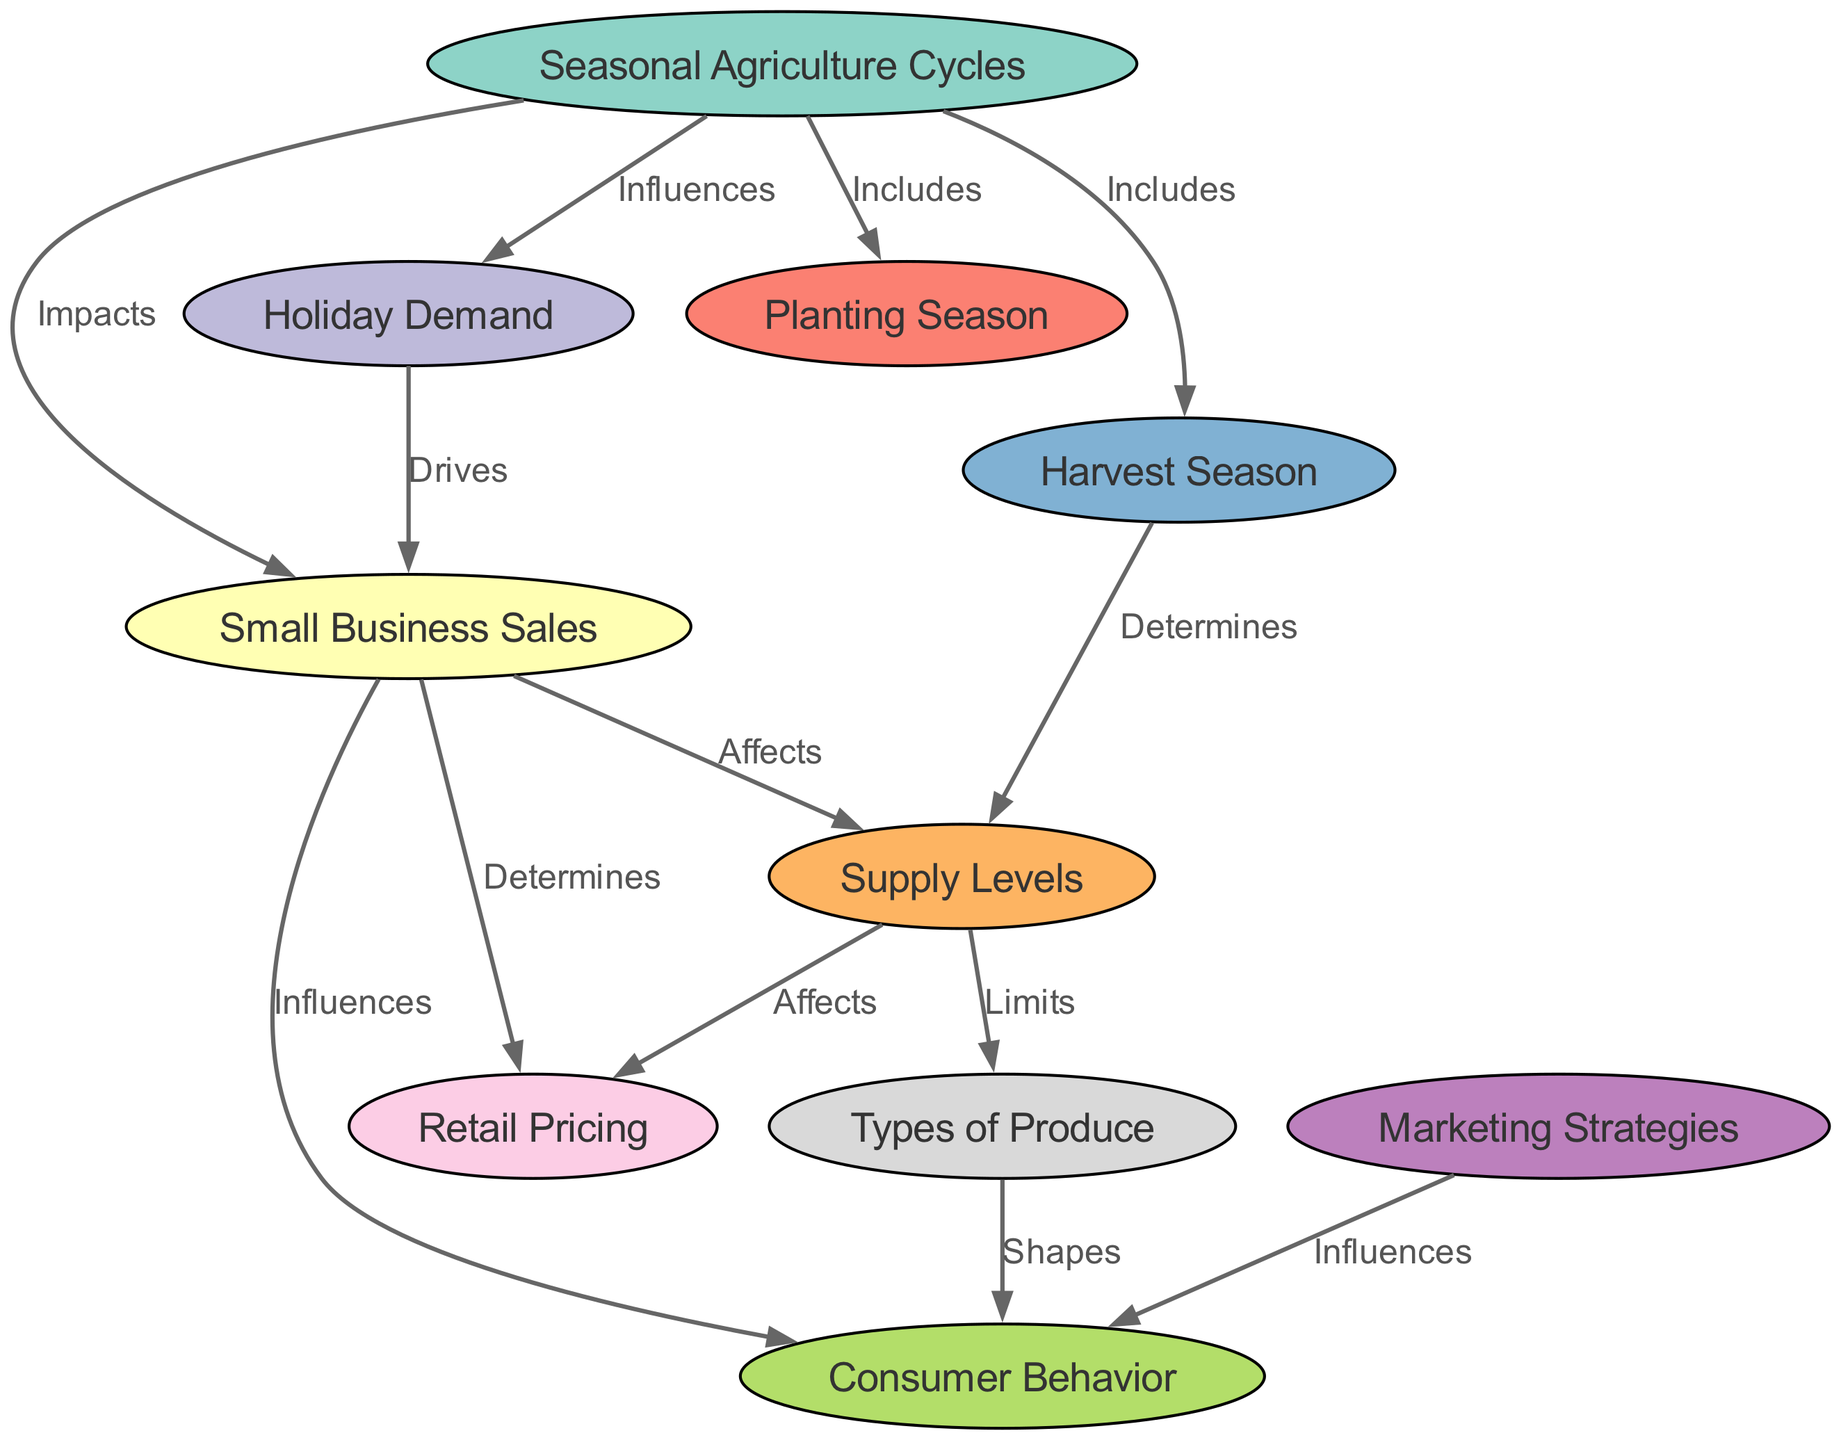What are the types of seasons included in seasonal agriculture cycles? The diagram indicates that the seasonal agriculture cycles include both planting and harvest seasons, as stated directly in the edges connecting these nodes to the seasonal_cycles node.
Answer: Planting Season, Harvest Season How many nodes are in the diagram? By counting all nodes listed in the provided data, we find there are 10 distinct nodes.
Answer: 10 What does holiday demand drive? According to the diagram, holiday demand drives small business sales, as shown by the edge connecting those two nodes labeled "Drives".
Answer: Small Business Sales How do supply levels affect retail pricing? The connection between supply levels and retail pricing indicates that supply levels affect retail pricing, as noted on the edge in the diagram that states "Affects".
Answer: Affects Which node shapes consumer behavior? The diagram shows that produce types shape consumer behavior, as depicted by the edge labeled "Shapes" connecting these two nodes.
Answer: Produce Types What influences consumer behavior besides produce types? In addition to produce types, marketing strategies also influence consumer behavior, as indicated by the corresponding edge in the diagram.
Answer: Marketing Strategies What impacts small business sales from seasonal agriculture cycles? The connection from seasonal agriculture cycles to small business sales agrees that these cycles impact the sales, as represented by the edge labeled "Impacts".
Answer: Impacts Which season determines supply levels? The diagram specifies that the harvest season determines supply levels, shown by the edge stating "Determines" between these nodes.
Answer: Harvest Season What limits the types of produce? The relationship illustrated in the diagram indicates that supply levels limit the types of produce, as discerned from the edge labeled "Limits".
Answer: Supply Levels 